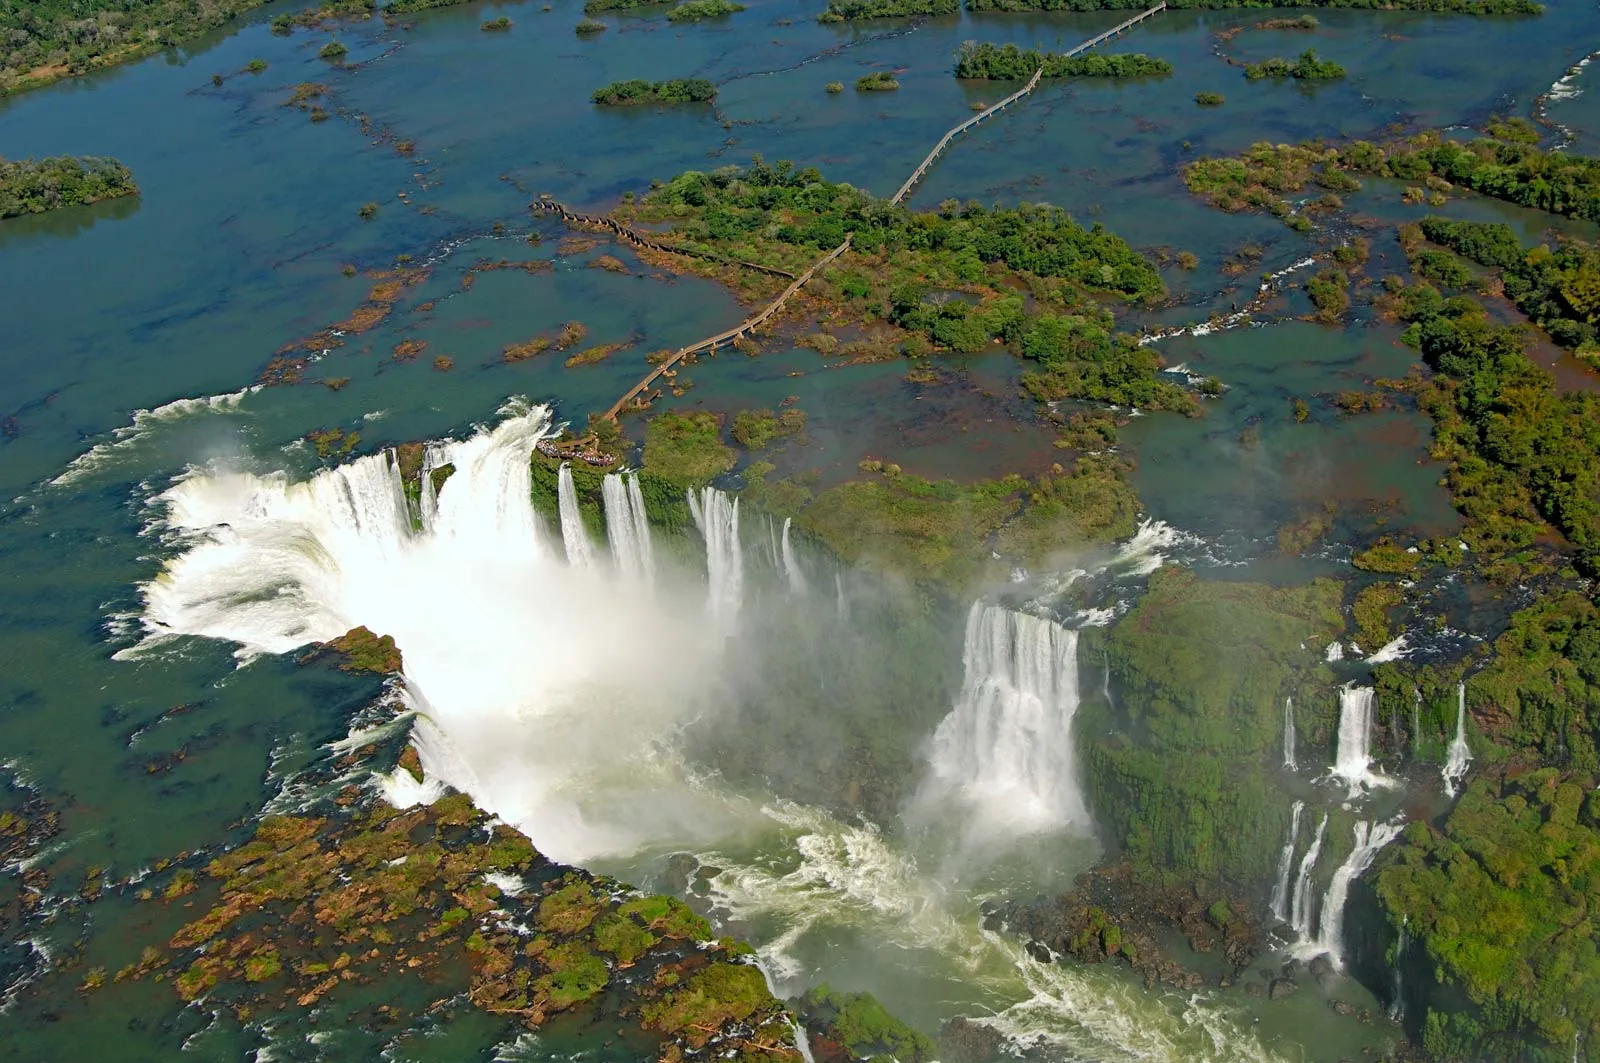Can you describe a day at the Iguazu Falls? A day at the Iguazu Falls begins with an early morning mist rising from the falls, blending with the first light of dawn. As you make your way along the wooden walkways, you hear the growing roar of the water long before you see it. The sun climbs higher, casting rainbows through the mist as the falls come into view—breathtakingly powerful and stunning. You might take a boat ride or hike along the trails, sensing the dense tropical humidity and the rich scent of the forest. You picnic amidst the symphony of nature while macaws call and butterflies dance in the sunlight. As evening approaches, the falls become a subdued presence, the lights dimming and the sounds blending into the background of a tranquil, fading day. How might the ecosystem around the falls be impacted by seasonal changes? The ecosystem around Iguazu Falls is profoundly influenced by seasonal changes. During the rainy season, the falls swell and become even more powerful, drawing more moisture to the surrounding flora and supporting verdant growth. Rivers and streams in the area also increase in size, potentially affecting the habitats of aquatic and semi-aquatic species. Conversely, the dry season leads to a reduction in water flow, which may expose more rock faces around the falls and concentrate aquatic life into smaller areas. The varieties of plant life might adapt by reducing their water needs or going into dormancy. Migratory birds and other wildlife often adjust their behaviors and locations based on these seasonal shifts, ensuring the delicate balance of the ecosystem is maintained. If the falls could 'speak', what stories might they tell? If the Iguazu Falls could speak, imagine the tales they could share! They might start with ancient legends of creation, where gods and spirits shaped the land. Stories of the indigenous Guarani people who regarded the falls as a sacred site, a place where earth and water collided in harmony. The falls could describe encounters with early explorers, the awe of the first humans to witness their majesty, and moments of sheer wonder as thousands of visitors from all over the world stood transfixed by their power. They would recall the ebb and flow of seasons, witnessing the cycles of nature—birth, growth, death, and rebirth—all played out within their vicinity. The falls would even tell us about the quiet times, under the moonlight when the world is silent and serene, a hidden, magical universe just for those who listen. 